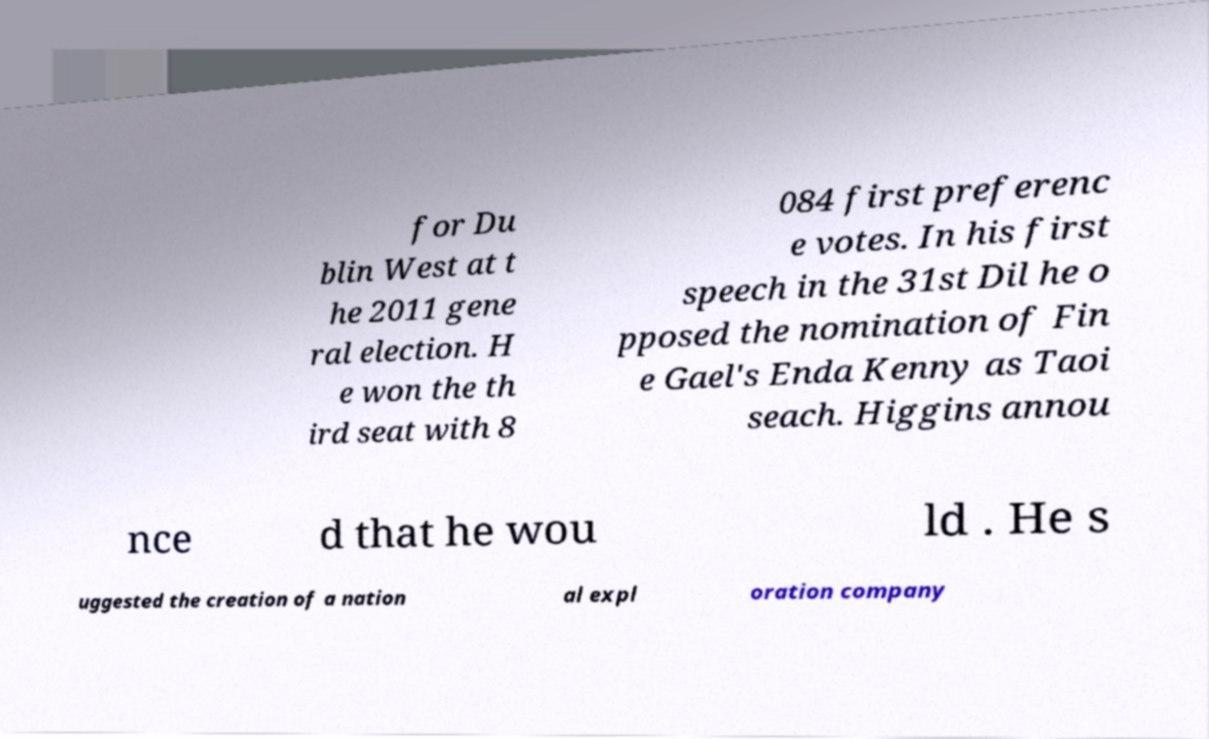Could you extract and type out the text from this image? for Du blin West at t he 2011 gene ral election. H e won the th ird seat with 8 084 first preferenc e votes. In his first speech in the 31st Dil he o pposed the nomination of Fin e Gael's Enda Kenny as Taoi seach. Higgins annou nce d that he wou ld . He s uggested the creation of a nation al expl oration company 